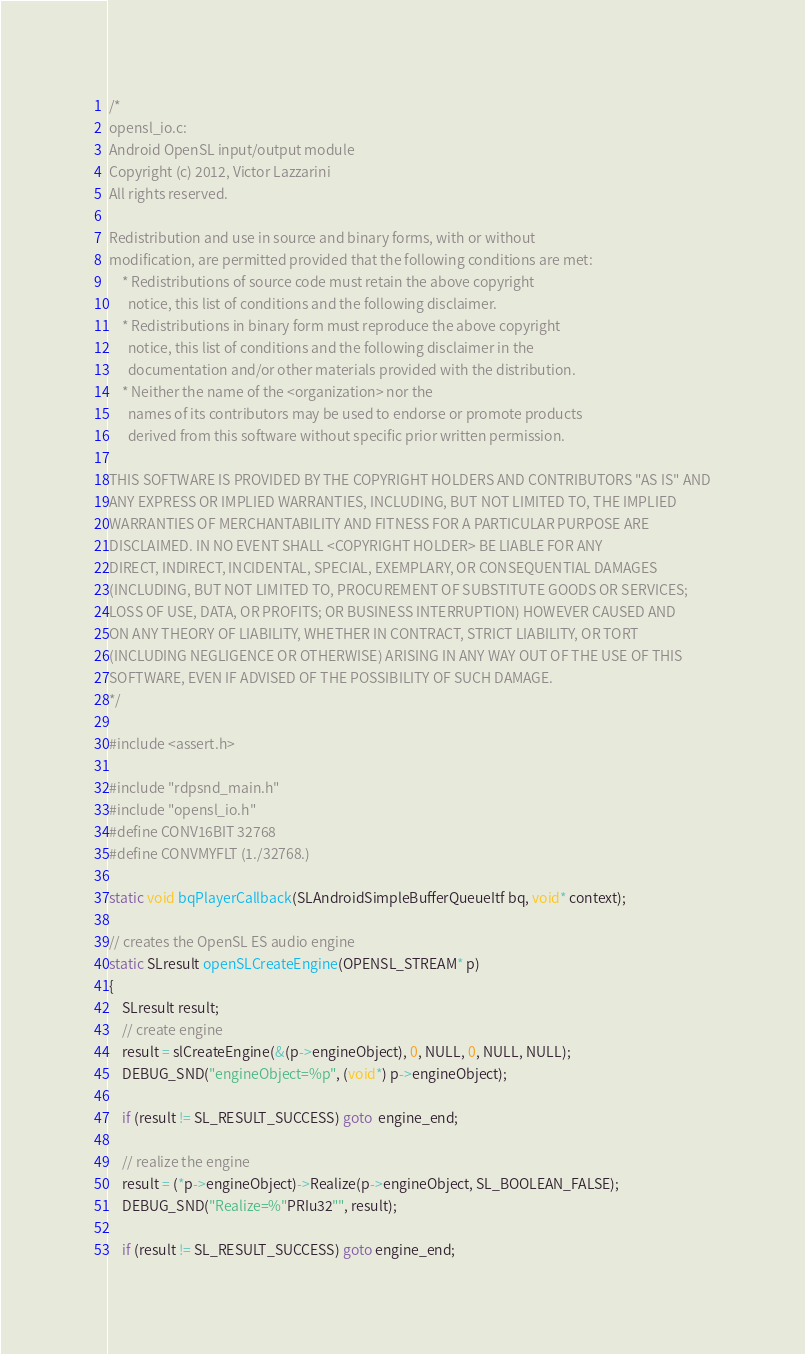Convert code to text. <code><loc_0><loc_0><loc_500><loc_500><_C_>/*
opensl_io.c:
Android OpenSL input/output module
Copyright (c) 2012, Victor Lazzarini
All rights reserved.

Redistribution and use in source and binary forms, with or without
modification, are permitted provided that the following conditions are met:
	* Redistributions of source code must retain the above copyright
	  notice, this list of conditions and the following disclaimer.
	* Redistributions in binary form must reproduce the above copyright
	  notice, this list of conditions and the following disclaimer in the
	  documentation and/or other materials provided with the distribution.
	* Neither the name of the <organization> nor the
	  names of its contributors may be used to endorse or promote products
	  derived from this software without specific prior written permission.

THIS SOFTWARE IS PROVIDED BY THE COPYRIGHT HOLDERS AND CONTRIBUTORS "AS IS" AND
ANY EXPRESS OR IMPLIED WARRANTIES, INCLUDING, BUT NOT LIMITED TO, THE IMPLIED
WARRANTIES OF MERCHANTABILITY AND FITNESS FOR A PARTICULAR PURPOSE ARE
DISCLAIMED. IN NO EVENT SHALL <COPYRIGHT HOLDER> BE LIABLE FOR ANY
DIRECT, INDIRECT, INCIDENTAL, SPECIAL, EXEMPLARY, OR CONSEQUENTIAL DAMAGES
(INCLUDING, BUT NOT LIMITED TO, PROCUREMENT OF SUBSTITUTE GOODS OR SERVICES;
LOSS OF USE, DATA, OR PROFITS; OR BUSINESS INTERRUPTION) HOWEVER CAUSED AND
ON ANY THEORY OF LIABILITY, WHETHER IN CONTRACT, STRICT LIABILITY, OR TORT
(INCLUDING NEGLIGENCE OR OTHERWISE) ARISING IN ANY WAY OUT OF THE USE OF THIS
SOFTWARE, EVEN IF ADVISED OF THE POSSIBILITY OF SUCH DAMAGE.
*/

#include <assert.h>

#include "rdpsnd_main.h"
#include "opensl_io.h"
#define CONV16BIT 32768
#define CONVMYFLT (1./32768.)

static void bqPlayerCallback(SLAndroidSimpleBufferQueueItf bq, void* context);

// creates the OpenSL ES audio engine
static SLresult openSLCreateEngine(OPENSL_STREAM* p)
{
	SLresult result;
	// create engine
	result = slCreateEngine(&(p->engineObject), 0, NULL, 0, NULL, NULL);
	DEBUG_SND("engineObject=%p", (void*) p->engineObject);

	if (result != SL_RESULT_SUCCESS) goto  engine_end;

	// realize the engine
	result = (*p->engineObject)->Realize(p->engineObject, SL_BOOLEAN_FALSE);
	DEBUG_SND("Realize=%"PRIu32"", result);

	if (result != SL_RESULT_SUCCESS) goto engine_end;
</code> 